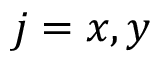Convert formula to latex. <formula><loc_0><loc_0><loc_500><loc_500>j = x , y</formula> 